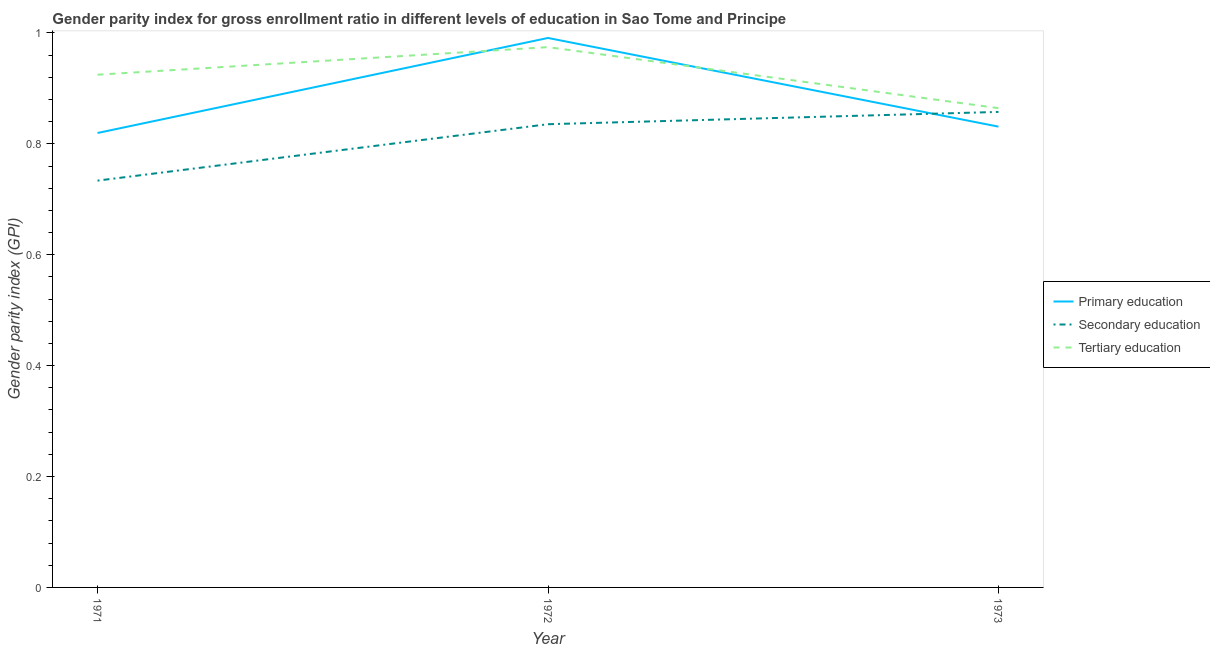What is the gender parity index in secondary education in 1971?
Give a very brief answer. 0.73. Across all years, what is the maximum gender parity index in tertiary education?
Provide a succinct answer. 0.97. Across all years, what is the minimum gender parity index in primary education?
Keep it short and to the point. 0.82. What is the total gender parity index in secondary education in the graph?
Offer a very short reply. 2.43. What is the difference between the gender parity index in tertiary education in 1971 and that in 1972?
Your answer should be compact. -0.05. What is the difference between the gender parity index in secondary education in 1971 and the gender parity index in tertiary education in 1973?
Provide a succinct answer. -0.13. What is the average gender parity index in primary education per year?
Make the answer very short. 0.88. In the year 1972, what is the difference between the gender parity index in primary education and gender parity index in tertiary education?
Give a very brief answer. 0.02. In how many years, is the gender parity index in primary education greater than 0.8400000000000001?
Give a very brief answer. 1. What is the ratio of the gender parity index in tertiary education in 1971 to that in 1972?
Give a very brief answer. 0.95. Is the difference between the gender parity index in primary education in 1972 and 1973 greater than the difference between the gender parity index in secondary education in 1972 and 1973?
Give a very brief answer. Yes. What is the difference between the highest and the second highest gender parity index in tertiary education?
Your answer should be compact. 0.05. What is the difference between the highest and the lowest gender parity index in tertiary education?
Your answer should be compact. 0.11. Does the gender parity index in tertiary education monotonically increase over the years?
Offer a very short reply. No. Is the gender parity index in tertiary education strictly greater than the gender parity index in secondary education over the years?
Ensure brevity in your answer.  Yes. How many legend labels are there?
Offer a very short reply. 3. How are the legend labels stacked?
Your answer should be very brief. Vertical. What is the title of the graph?
Your answer should be very brief. Gender parity index for gross enrollment ratio in different levels of education in Sao Tome and Principe. Does "Maunufacturing" appear as one of the legend labels in the graph?
Your response must be concise. No. What is the label or title of the Y-axis?
Your answer should be very brief. Gender parity index (GPI). What is the Gender parity index (GPI) in Primary education in 1971?
Your answer should be very brief. 0.82. What is the Gender parity index (GPI) of Secondary education in 1971?
Your answer should be very brief. 0.73. What is the Gender parity index (GPI) of Tertiary education in 1971?
Your answer should be compact. 0.92. What is the Gender parity index (GPI) in Primary education in 1972?
Ensure brevity in your answer.  0.99. What is the Gender parity index (GPI) in Secondary education in 1972?
Provide a succinct answer. 0.84. What is the Gender parity index (GPI) of Tertiary education in 1972?
Your response must be concise. 0.97. What is the Gender parity index (GPI) in Primary education in 1973?
Make the answer very short. 0.83. What is the Gender parity index (GPI) in Secondary education in 1973?
Give a very brief answer. 0.86. What is the Gender parity index (GPI) of Tertiary education in 1973?
Give a very brief answer. 0.86. Across all years, what is the maximum Gender parity index (GPI) of Primary education?
Provide a succinct answer. 0.99. Across all years, what is the maximum Gender parity index (GPI) of Secondary education?
Provide a short and direct response. 0.86. Across all years, what is the maximum Gender parity index (GPI) of Tertiary education?
Your response must be concise. 0.97. Across all years, what is the minimum Gender parity index (GPI) in Primary education?
Offer a very short reply. 0.82. Across all years, what is the minimum Gender parity index (GPI) of Secondary education?
Offer a terse response. 0.73. Across all years, what is the minimum Gender parity index (GPI) of Tertiary education?
Your response must be concise. 0.86. What is the total Gender parity index (GPI) of Primary education in the graph?
Your response must be concise. 2.64. What is the total Gender parity index (GPI) in Secondary education in the graph?
Your answer should be very brief. 2.43. What is the total Gender parity index (GPI) in Tertiary education in the graph?
Ensure brevity in your answer.  2.76. What is the difference between the Gender parity index (GPI) of Primary education in 1971 and that in 1972?
Keep it short and to the point. -0.17. What is the difference between the Gender parity index (GPI) in Secondary education in 1971 and that in 1972?
Your answer should be very brief. -0.1. What is the difference between the Gender parity index (GPI) in Tertiary education in 1971 and that in 1972?
Provide a succinct answer. -0.05. What is the difference between the Gender parity index (GPI) in Primary education in 1971 and that in 1973?
Give a very brief answer. -0.01. What is the difference between the Gender parity index (GPI) in Secondary education in 1971 and that in 1973?
Provide a short and direct response. -0.12. What is the difference between the Gender parity index (GPI) in Tertiary education in 1971 and that in 1973?
Ensure brevity in your answer.  0.06. What is the difference between the Gender parity index (GPI) of Primary education in 1972 and that in 1973?
Make the answer very short. 0.16. What is the difference between the Gender parity index (GPI) of Secondary education in 1972 and that in 1973?
Your answer should be very brief. -0.02. What is the difference between the Gender parity index (GPI) in Tertiary education in 1972 and that in 1973?
Your answer should be very brief. 0.11. What is the difference between the Gender parity index (GPI) of Primary education in 1971 and the Gender parity index (GPI) of Secondary education in 1972?
Your answer should be very brief. -0.02. What is the difference between the Gender parity index (GPI) in Primary education in 1971 and the Gender parity index (GPI) in Tertiary education in 1972?
Your answer should be very brief. -0.15. What is the difference between the Gender parity index (GPI) in Secondary education in 1971 and the Gender parity index (GPI) in Tertiary education in 1972?
Offer a terse response. -0.24. What is the difference between the Gender parity index (GPI) in Primary education in 1971 and the Gender parity index (GPI) in Secondary education in 1973?
Make the answer very short. -0.04. What is the difference between the Gender parity index (GPI) in Primary education in 1971 and the Gender parity index (GPI) in Tertiary education in 1973?
Keep it short and to the point. -0.04. What is the difference between the Gender parity index (GPI) in Secondary education in 1971 and the Gender parity index (GPI) in Tertiary education in 1973?
Offer a terse response. -0.13. What is the difference between the Gender parity index (GPI) in Primary education in 1972 and the Gender parity index (GPI) in Secondary education in 1973?
Your answer should be very brief. 0.13. What is the difference between the Gender parity index (GPI) in Primary education in 1972 and the Gender parity index (GPI) in Tertiary education in 1973?
Provide a succinct answer. 0.13. What is the difference between the Gender parity index (GPI) in Secondary education in 1972 and the Gender parity index (GPI) in Tertiary education in 1973?
Provide a short and direct response. -0.03. What is the average Gender parity index (GPI) of Primary education per year?
Provide a short and direct response. 0.88. What is the average Gender parity index (GPI) in Secondary education per year?
Your response must be concise. 0.81. What is the average Gender parity index (GPI) of Tertiary education per year?
Ensure brevity in your answer.  0.92. In the year 1971, what is the difference between the Gender parity index (GPI) in Primary education and Gender parity index (GPI) in Secondary education?
Offer a very short reply. 0.09. In the year 1971, what is the difference between the Gender parity index (GPI) of Primary education and Gender parity index (GPI) of Tertiary education?
Offer a terse response. -0.11. In the year 1971, what is the difference between the Gender parity index (GPI) of Secondary education and Gender parity index (GPI) of Tertiary education?
Your answer should be very brief. -0.19. In the year 1972, what is the difference between the Gender parity index (GPI) in Primary education and Gender parity index (GPI) in Secondary education?
Offer a very short reply. 0.16. In the year 1972, what is the difference between the Gender parity index (GPI) of Primary education and Gender parity index (GPI) of Tertiary education?
Ensure brevity in your answer.  0.02. In the year 1972, what is the difference between the Gender parity index (GPI) of Secondary education and Gender parity index (GPI) of Tertiary education?
Your answer should be very brief. -0.14. In the year 1973, what is the difference between the Gender parity index (GPI) of Primary education and Gender parity index (GPI) of Secondary education?
Keep it short and to the point. -0.03. In the year 1973, what is the difference between the Gender parity index (GPI) in Primary education and Gender parity index (GPI) in Tertiary education?
Your response must be concise. -0.03. In the year 1973, what is the difference between the Gender parity index (GPI) in Secondary education and Gender parity index (GPI) in Tertiary education?
Offer a terse response. -0.01. What is the ratio of the Gender parity index (GPI) in Primary education in 1971 to that in 1972?
Make the answer very short. 0.83. What is the ratio of the Gender parity index (GPI) of Secondary education in 1971 to that in 1972?
Offer a terse response. 0.88. What is the ratio of the Gender parity index (GPI) in Tertiary education in 1971 to that in 1972?
Your answer should be compact. 0.95. What is the ratio of the Gender parity index (GPI) in Primary education in 1971 to that in 1973?
Your answer should be very brief. 0.99. What is the ratio of the Gender parity index (GPI) of Secondary education in 1971 to that in 1973?
Offer a very short reply. 0.86. What is the ratio of the Gender parity index (GPI) of Tertiary education in 1971 to that in 1973?
Your answer should be compact. 1.07. What is the ratio of the Gender parity index (GPI) of Primary education in 1972 to that in 1973?
Your answer should be very brief. 1.19. What is the ratio of the Gender parity index (GPI) of Secondary education in 1972 to that in 1973?
Your answer should be compact. 0.97. What is the ratio of the Gender parity index (GPI) in Tertiary education in 1972 to that in 1973?
Provide a short and direct response. 1.13. What is the difference between the highest and the second highest Gender parity index (GPI) of Primary education?
Provide a succinct answer. 0.16. What is the difference between the highest and the second highest Gender parity index (GPI) of Secondary education?
Your response must be concise. 0.02. What is the difference between the highest and the second highest Gender parity index (GPI) in Tertiary education?
Make the answer very short. 0.05. What is the difference between the highest and the lowest Gender parity index (GPI) in Primary education?
Your answer should be very brief. 0.17. What is the difference between the highest and the lowest Gender parity index (GPI) of Secondary education?
Make the answer very short. 0.12. What is the difference between the highest and the lowest Gender parity index (GPI) of Tertiary education?
Provide a short and direct response. 0.11. 